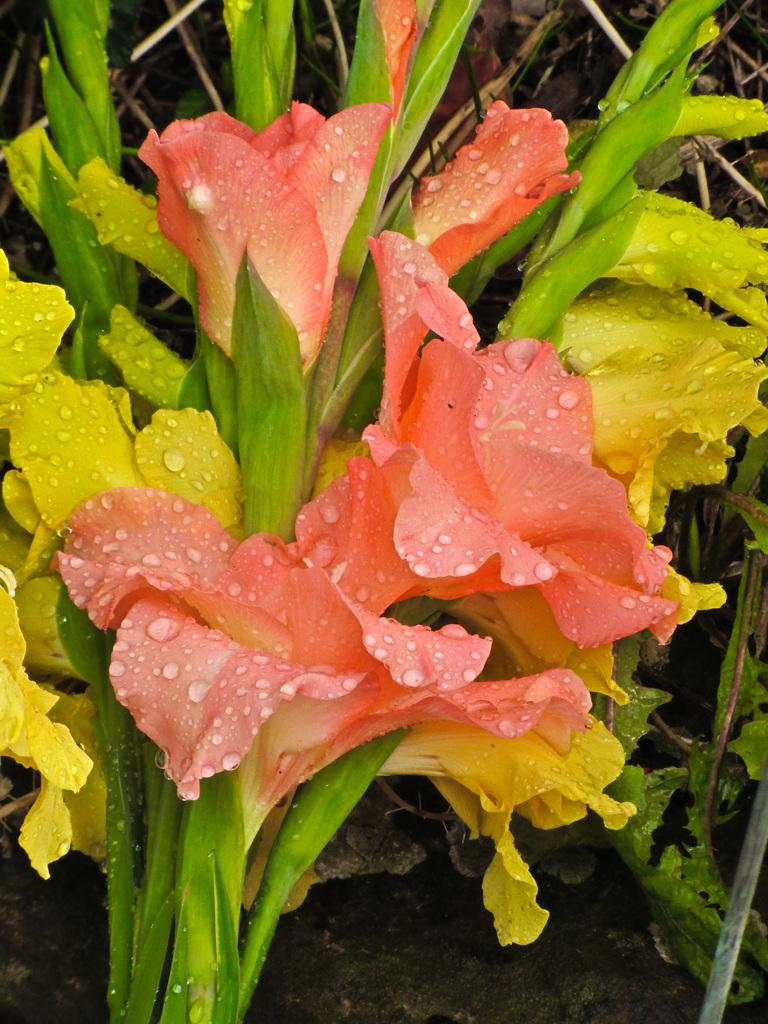What colors are the flowers in the image? The flowers in the image are orange and yellow. Can you describe the appearance of the flowers? The flowers have water droplets visible on them. What type of crime is being committed in the image? There is no crime present in the image; it features flowers with water droplets. What role does the sister play in the image? There is no mention of a sister in the image; it only features flowers with water droplets. 